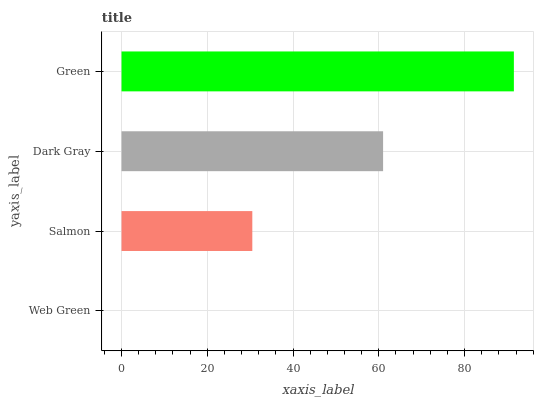Is Web Green the minimum?
Answer yes or no. Yes. Is Green the maximum?
Answer yes or no. Yes. Is Salmon the minimum?
Answer yes or no. No. Is Salmon the maximum?
Answer yes or no. No. Is Salmon greater than Web Green?
Answer yes or no. Yes. Is Web Green less than Salmon?
Answer yes or no. Yes. Is Web Green greater than Salmon?
Answer yes or no. No. Is Salmon less than Web Green?
Answer yes or no. No. Is Dark Gray the high median?
Answer yes or no. Yes. Is Salmon the low median?
Answer yes or no. Yes. Is Green the high median?
Answer yes or no. No. Is Web Green the low median?
Answer yes or no. No. 